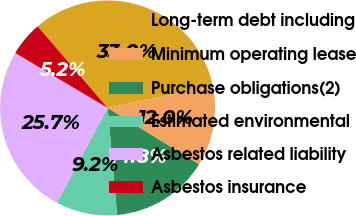Convert chart. <chart><loc_0><loc_0><loc_500><loc_500><pie_chart><fcel>Long-term debt including<fcel>Minimum operating lease<fcel>Purchase obligations(2)<fcel>Estimated environmental<fcel>Asbestos related liability<fcel>Asbestos insurance<nl><fcel>33.05%<fcel>12.02%<fcel>14.8%<fcel>9.23%<fcel>25.72%<fcel>5.19%<nl></chart> 